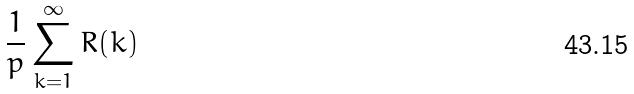<formula> <loc_0><loc_0><loc_500><loc_500>\frac { 1 } { p } \sum _ { k = 1 } ^ { \infty } R ( k )</formula> 